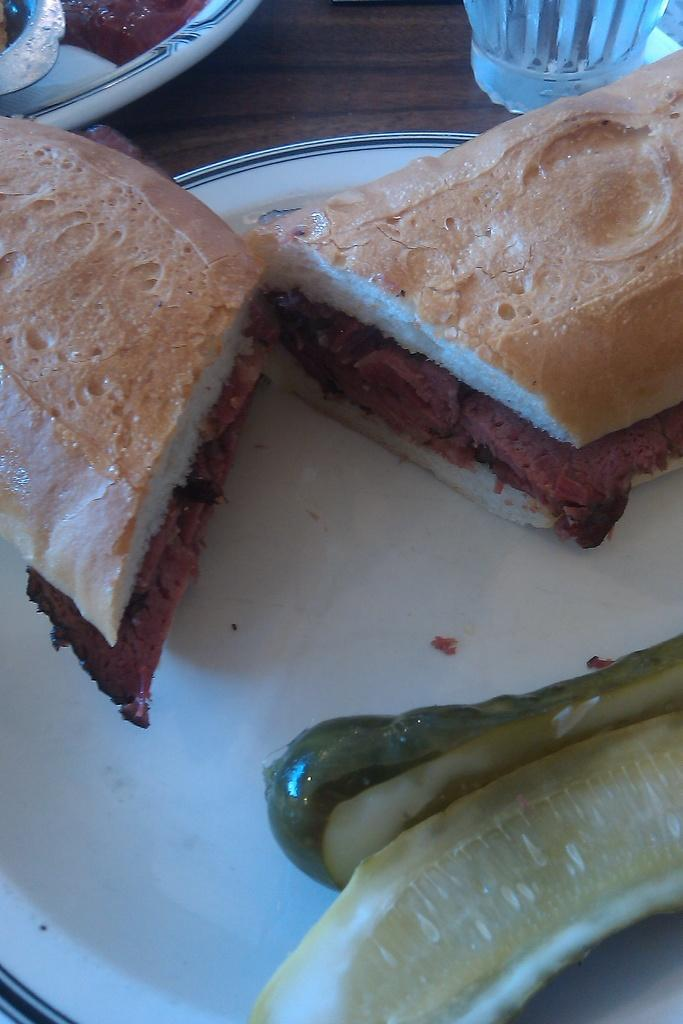What type of food is visible in the image? There are sandwiches in the image. What ingredient can be seen in the image? There is cucumber in the image. Where are the sandwiches and cucumber located? The sandwiches and cucumber are on a plate. How many plates are visible in the image? There is another plate visible in the image. Where are the plates placed? The plates are on a table. What material is the table made of? The table is made of wood. How does the van help measure the distance between the plates in the image? There is no van present in the image, and therefore it cannot help measure the distance between the plates. 